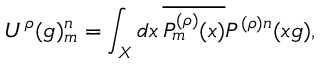<formula> <loc_0><loc_0><loc_500><loc_500>U ^ { \rho } ( g ) _ { m } ^ { n } = \int _ { X } d x \, \overline { { { P _ { m } ^ { ( \rho ) } ( x ) } } } P ^ { ( \rho ) n } ( x g ) ,</formula> 